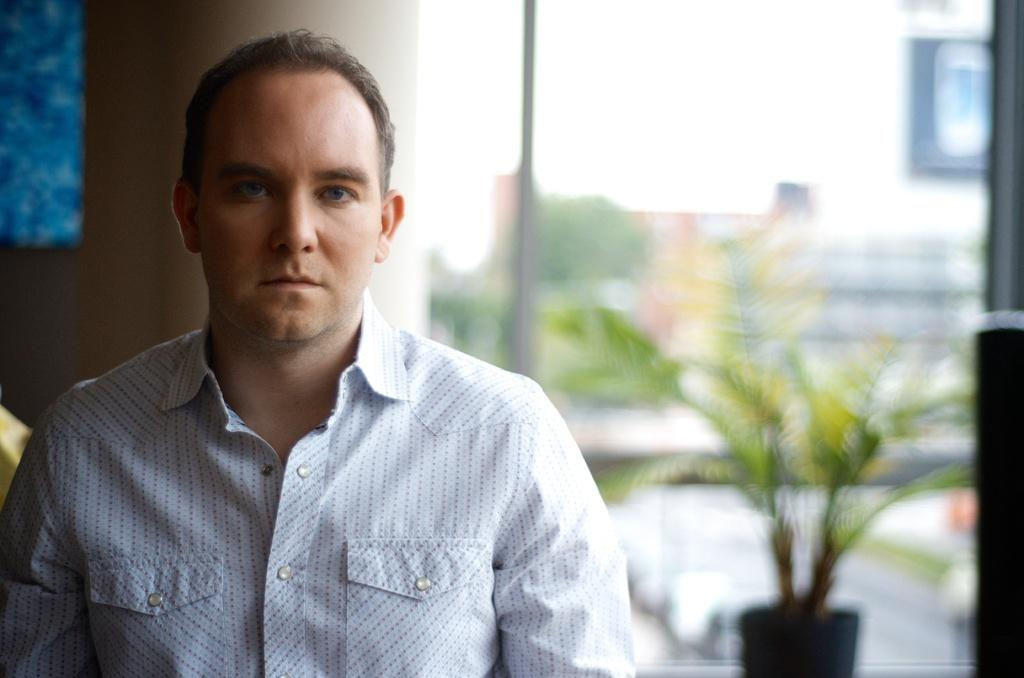What is the main subject of the image? There is a man standing in the image. What is the man wearing? The man is wearing a white shirt. What can be seen in the background of the image? There is a plant and a wall in the background of the image. What type of eggnog is being served in the image? There is no eggnog present in the image. How many people are joining the man in the image? The image only shows one man, so there is no one else joining him. 